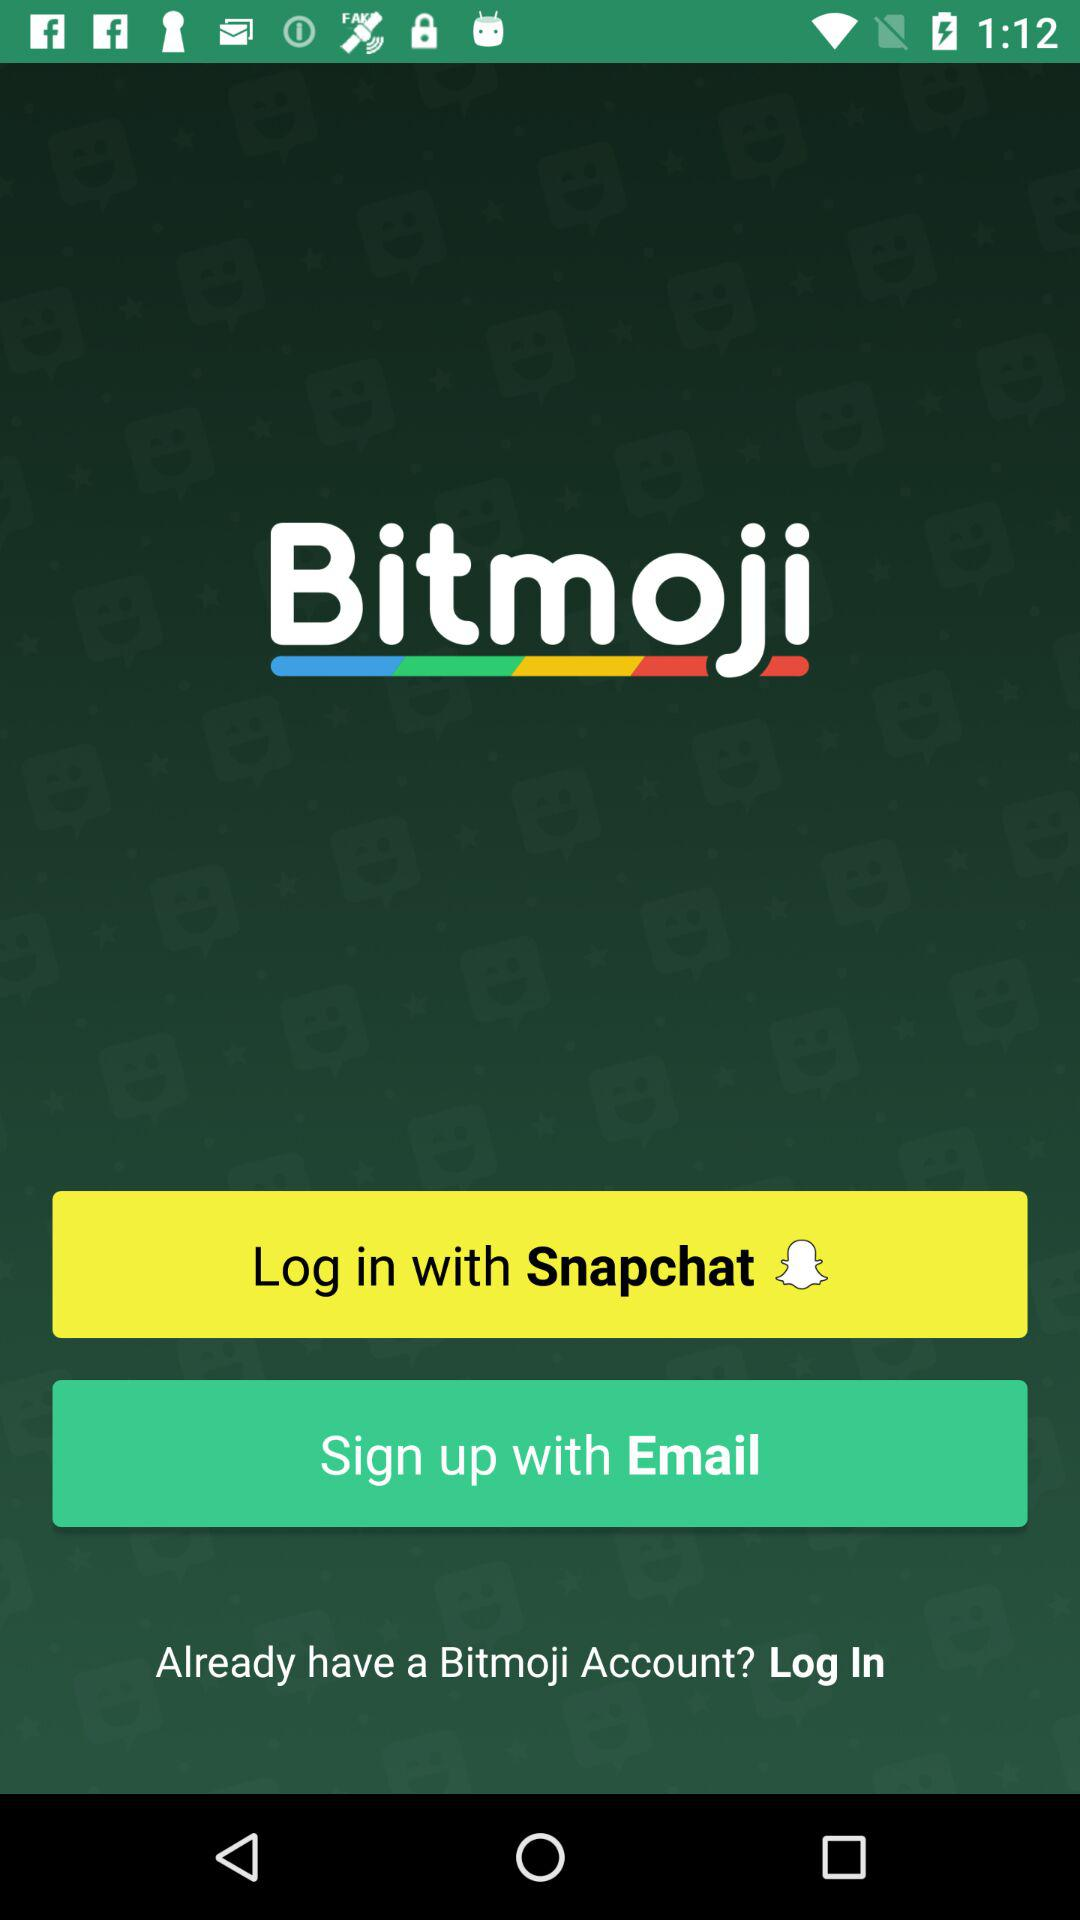What is the app name? The app name is "Bitmoji". 